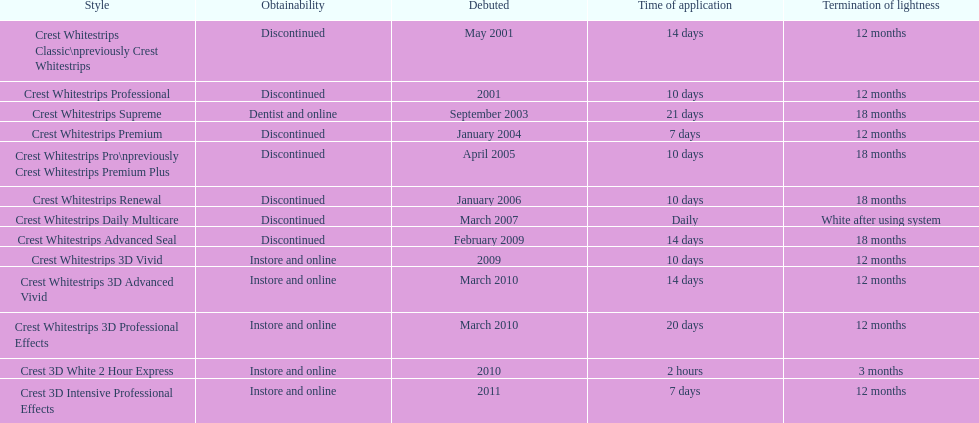Crest 3d intensive professional effects and crest whitestrips 3d professional effects both have a lasting whiteness of how many months? 12 months. 